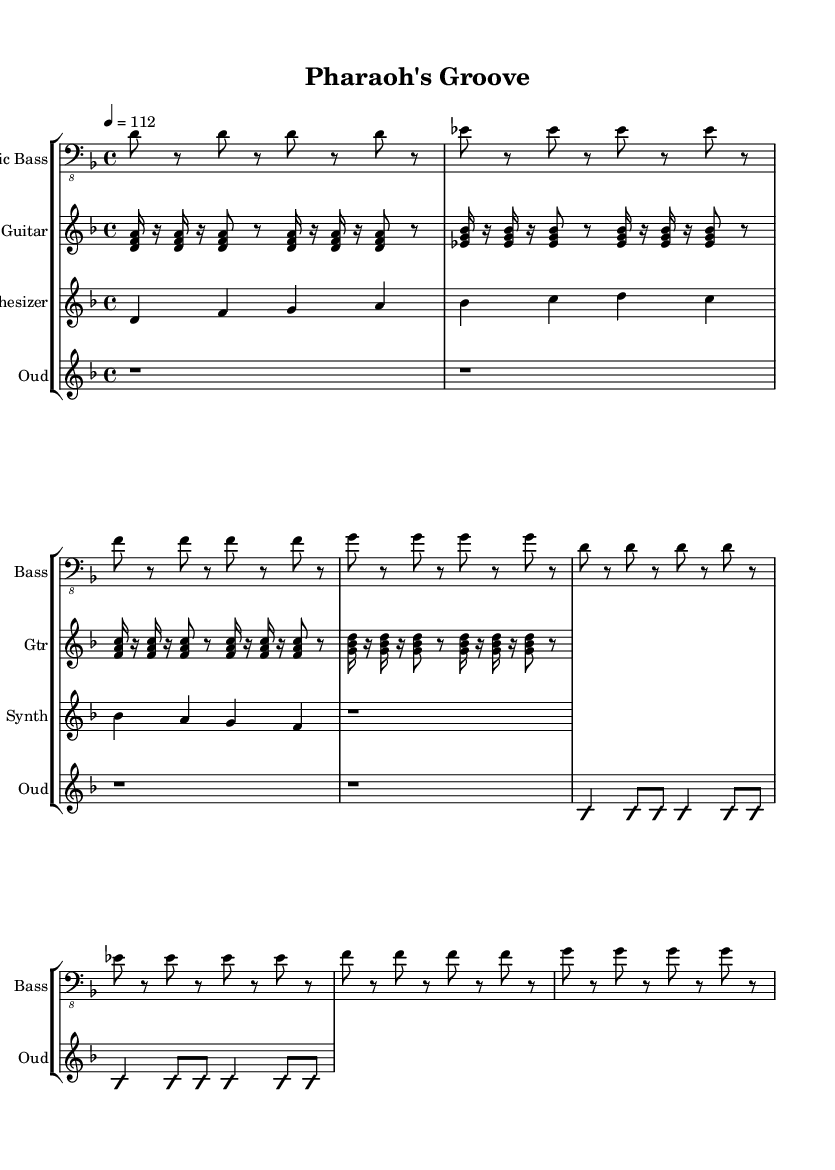What is the key signature of this music? The key signature at the beginning indicates two flats, which corresponds to D minor.
Answer: D minor What is the time signature of this music? The time signature is indicated in the beginning of the score as 4/4, meaning there are four beats in each measure.
Answer: 4/4 What is the tempo marking for this piece? The tempo marking shows '4 = 112', indicating a moderate tempo with a quarter note equaling 112 beats per minute.
Answer: 112 What instruments are featured in this composition? The score lists four instruments: Electric Bass, Electric Guitar, Synthesizer, and Oud.
Answer: Electric Bass, Electric Guitar, Synthesizer, Oud What type of melody is used in the Oud part? The Oud part features an improvisation section, as indicated by the 'improvisationOn' and 'improvisationOff' markings.
Answer: Improvisation How many bars does the synthesizer play the main theme? The synthesizer plays the main theme for one bar at the beginning and then rests for one bar, totaling two bars.
Answer: Two bars Which scale is predominantly used in the electric guitar's chords? The electric guitar plays chords based on D minor scales, as the chords correspond to the notes in that key signature.
Answer: D minor 